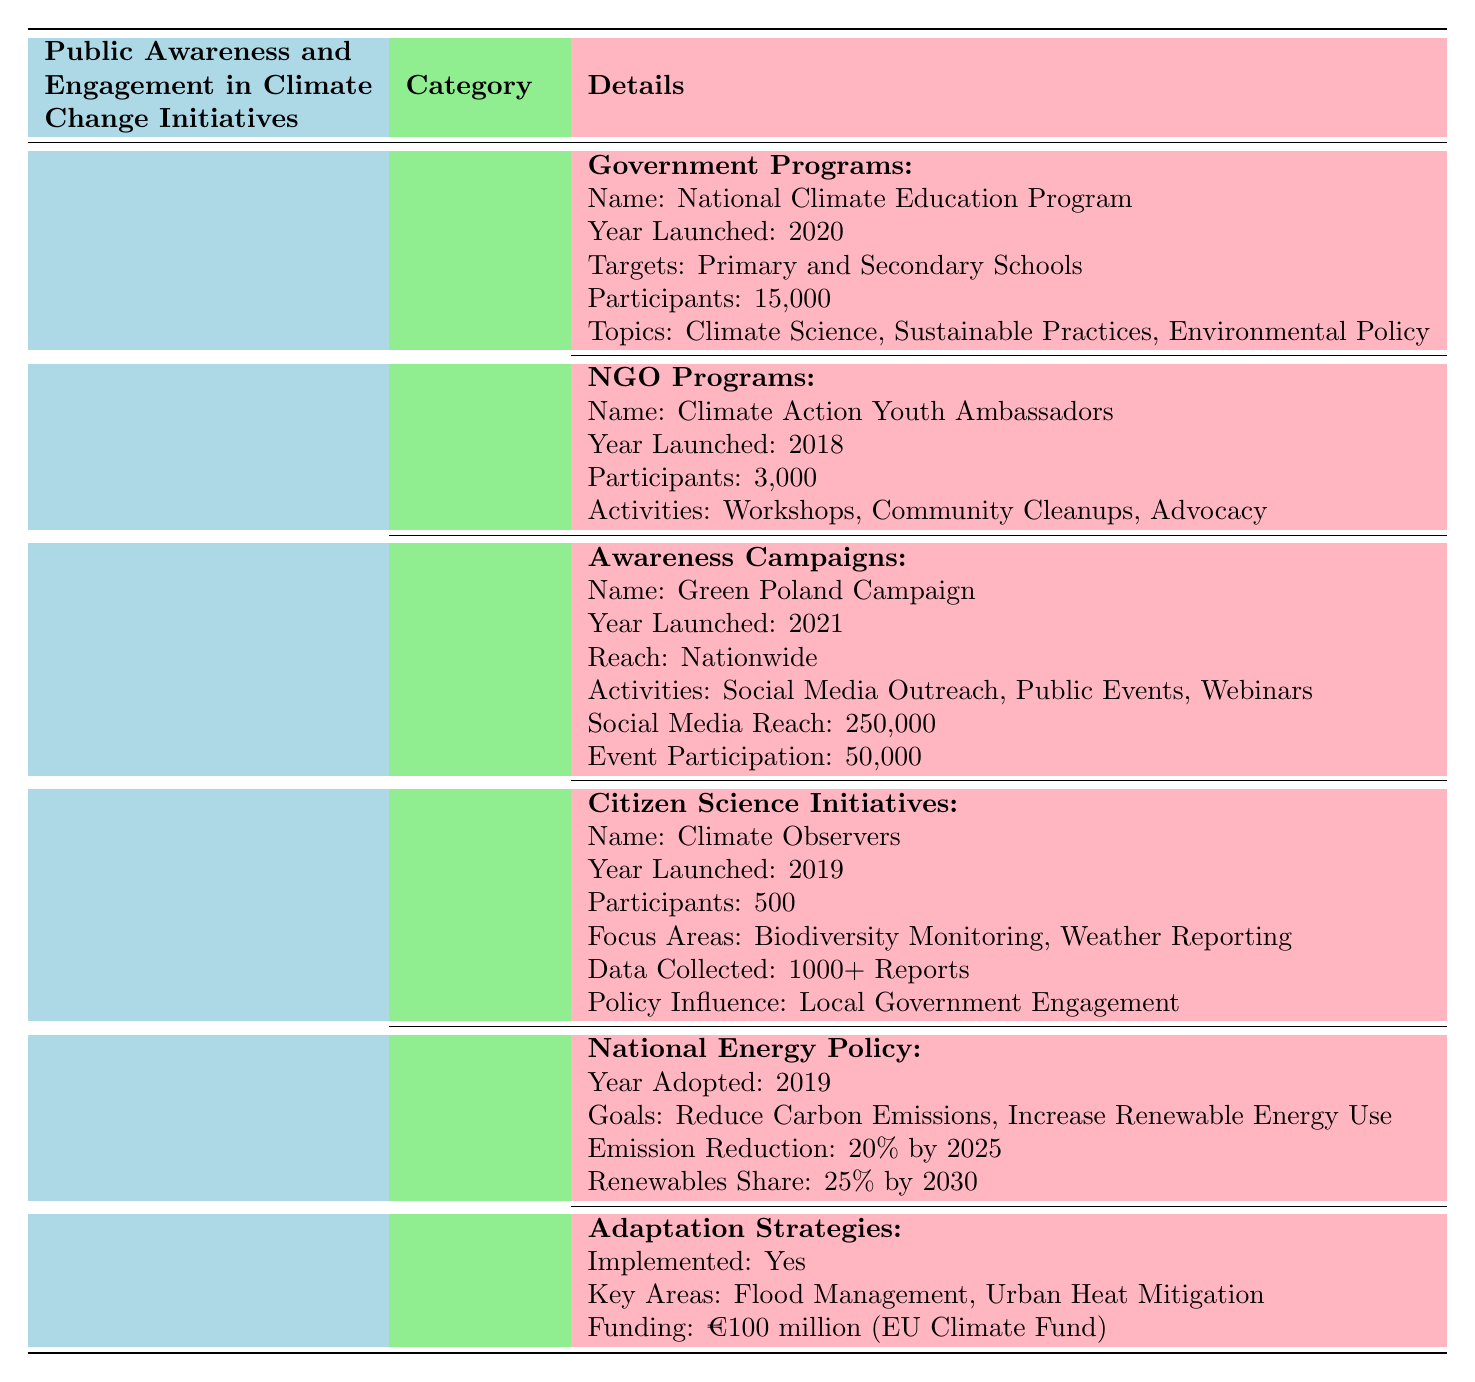What is the name of the government program focused on climate education in Poland? The table lists the government program under the "Educational Initiatives" section. The specific program mentioned is the "National Climate Education Program."
Answer: National Climate Education Program How many participants are involved in the NGO program "Climate Action Youth Ambassadors"? The table specifies that the NGO program "Climate Action Youth Ambassadors" had 3,000 participants listed under its details.
Answer: 3000 What is the target reach of the "Green Poland Campaign"? The table states the reach of the "Green Poland Campaign" is "Nationwide," indicating it aims to engage the entire country.
Answer: Nationwide Are there adaptation strategies implemented in government policies? The table indicates that adaptation strategies have been implemented, as it is clearly marked under the "Government Policies" section stating "Implemented: Yes."
Answer: Yes What is the total number of participants involved in educational initiatives provided by the government and NGOs combined? First, identify the number of participants in each initiative: 15,000 in the government program and 3,000 in the NGO program. Adding these figures together: 15,000 + 3,000 = 18,000 gives us the total.
Answer: 18000 What are the main focus areas of the "Climate Observers" citizen science initiative? The table lists the focus areas of the "Climate Observers" initiative as "Biodiversity Monitoring" and "Weather Reporting," which can be found in the details related to this initiative.
Answer: Biodiversity Monitoring, Weather Reporting What is the goal for renewable energy share in Poland by 2030 according to the National Energy Policy? The National Energy Policy section states the goal for renewable energy share is "25% by 2030," which can be directly referenced from the policy goals listed.
Answer: 25% by 2030 How many reports have been collected by the "Climate Observers"? The data indicates that the "Climate Observers" initiative has collected "1000+ Reports" as noted in the details of the initiative.
Answer: 1000+ Reports What year was the "Green Poland Campaign" launched? The table shows the "Green Poland Campaign" was launched in the year 2021, which is specified in the "Awareness Campaigns" section of public engagement.
Answer: 2021 